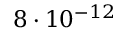Convert formula to latex. <formula><loc_0><loc_0><loc_500><loc_500>8 \cdot 1 0 ^ { - 1 2 }</formula> 